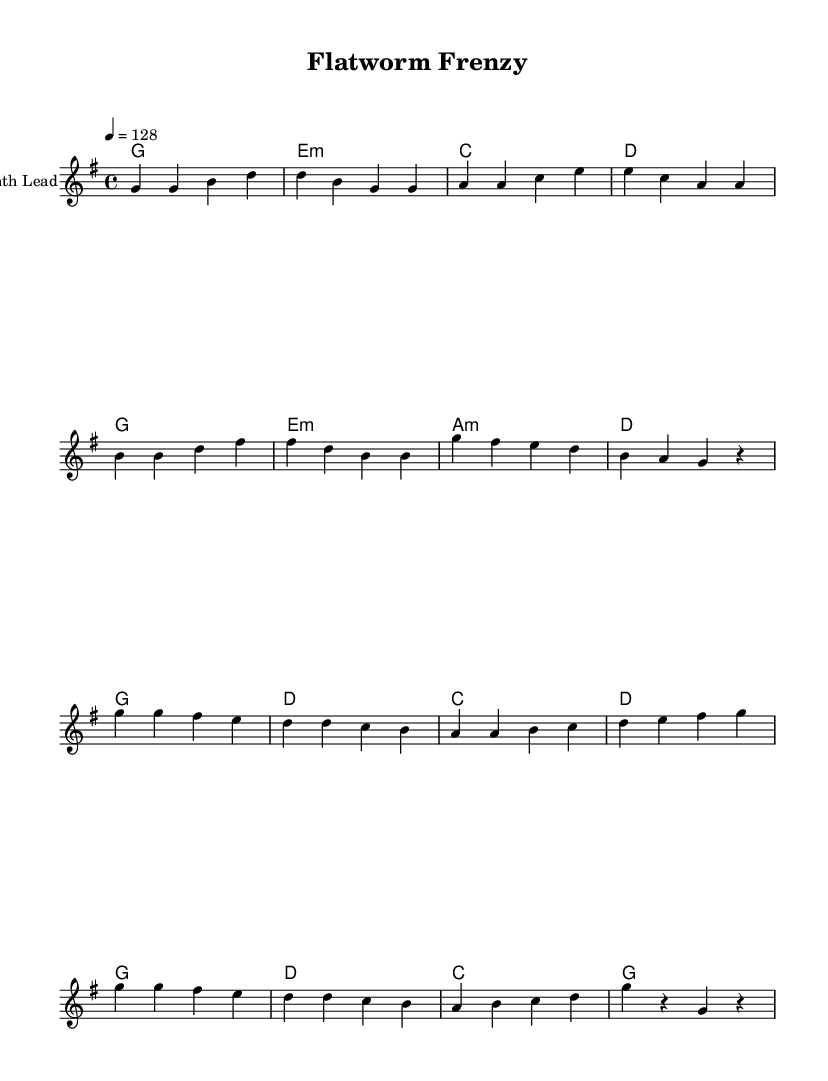What is the key signature of this music? The key signature is G major, indicated by one sharp (F#) in the key signature area of the sheet music.
Answer: G major What is the time signature of this music? The time signature is 4/4, which is shown at the beginning of the score next to the key signature. This indicates each measure has four beats.
Answer: 4/4 What is the tempo marking for this piece? The tempo marking states "4 = 128," which means there are 128 beats per minute at a quarter note, typical for energetic K-Pop dance songs.
Answer: 128 How many measures are in the chorus section? The chorus section has 8 measures and can be counted by identifying the section where the chorus begins and ends in the melody lines.
Answer: 8 What is the first chord used in the verse? The first chord of the verse is G major, as shown at the beginning of the verse section in the chord names.
Answer: G Which musical texture does this piece predominantly use? The piece mainly uses homophonic texture, as it features a melody supported by harmonies, typical in K-Pop music styles where the focus is on vocal or lead instrument alongside chord backing.
Answer: Homophonic What is the last note in the melody? The last note in the melody is a rest, which signifies a pause rather than a note being played; it appears at the end of the chorus.
Answer: Rest 